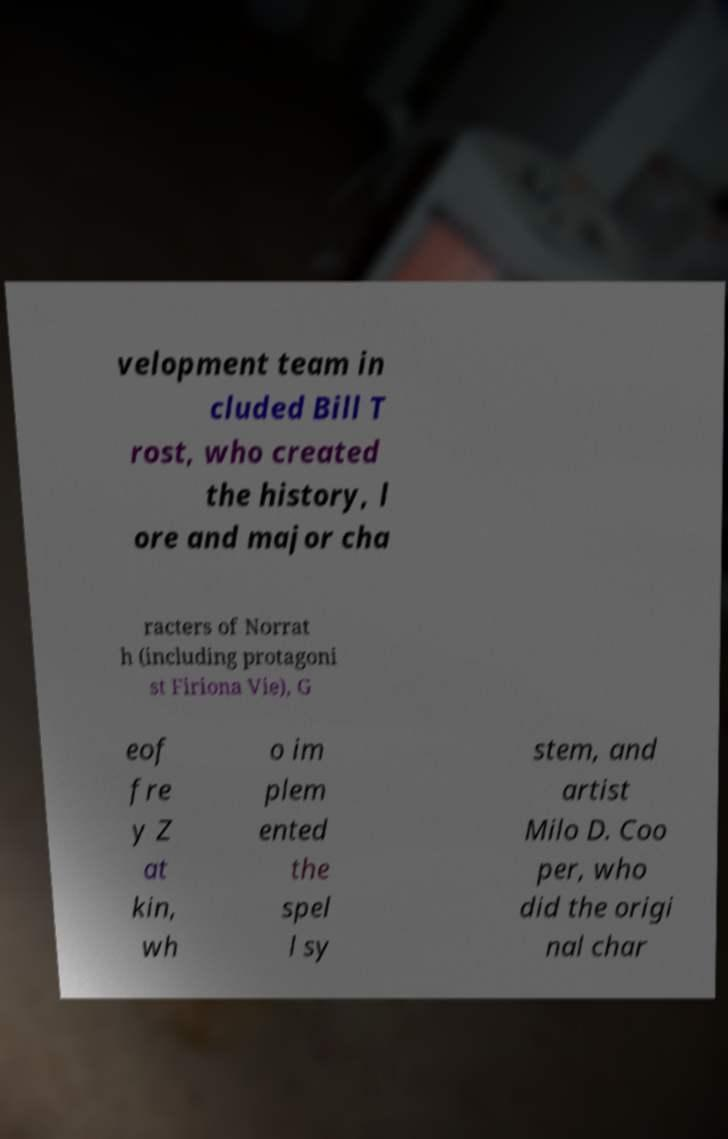What messages or text are displayed in this image? I need them in a readable, typed format. velopment team in cluded Bill T rost, who created the history, l ore and major cha racters of Norrat h (including protagoni st Firiona Vie), G eof fre y Z at kin, wh o im plem ented the spel l sy stem, and artist Milo D. Coo per, who did the origi nal char 